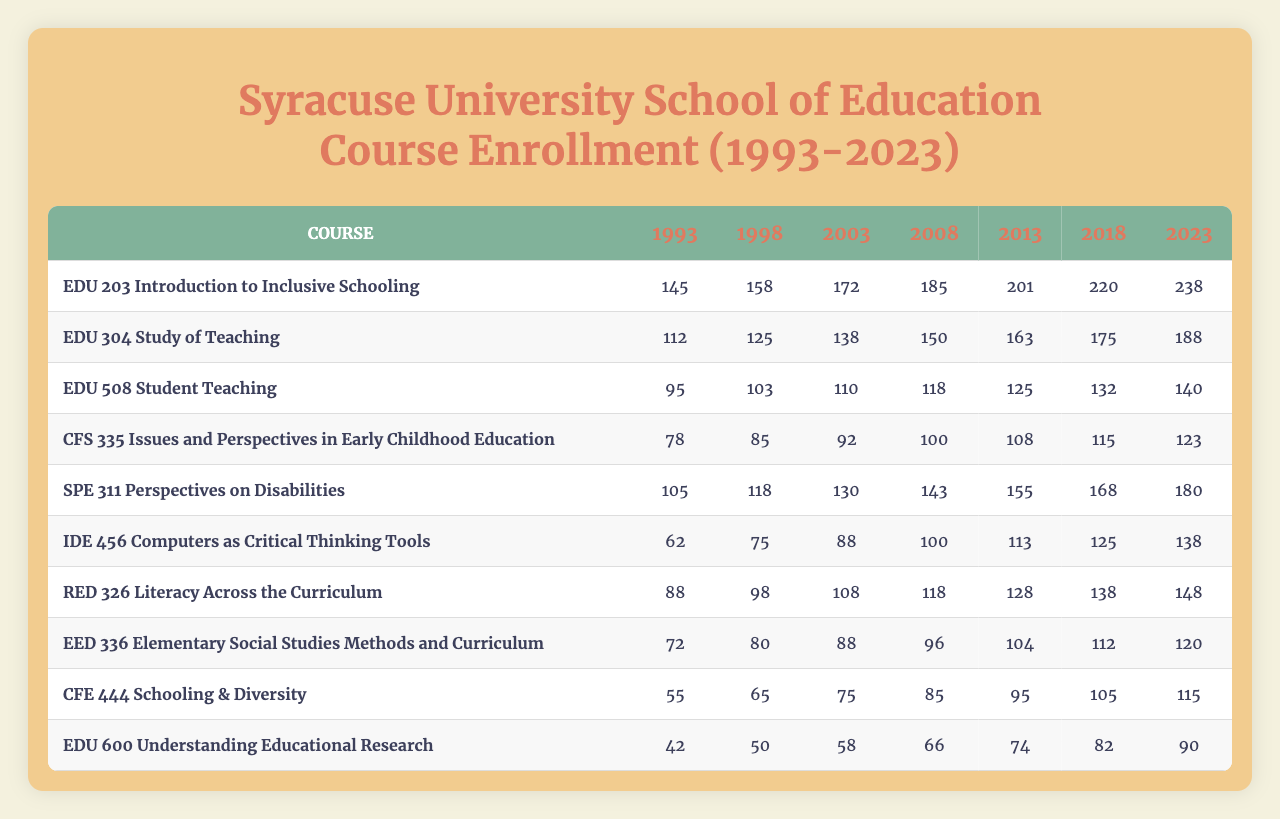What is the enrollment for "EDU 203 Introduction to Inclusive Schooling" in the year 2023? Referring to the table, locate the row for "EDU 203 Introduction to Inclusive Schooling" and find the corresponding value under the year 2023, which is 238.
Answer: 238 What is the highest enrollment recorded for "CFS 335 Issues and Perspectives in Early Childhood Education"? The highest enrollment can be determined by examining the enrollment numbers over the years provided in the row for "CFS 335 Issues and Perspectives in Early Childhood Education". The maximum value is 123 in the year 2023.
Answer: 123 Which course experienced the most significant increase in enrollment from 1993 to 2023? To find the course with the largest increase, calculate the difference between the enrollment numbers for each course in 1993 and 2023. Comparing the calculated differences, "EDU 203 Introduction to Inclusive Schooling" had the highest increase of 93 (from 145 to 238).
Answer: "EDU 203 Introduction to Inclusive Schooling" What is the average enrollment for "SPE 311 Perspectives on Disabilities" over the 30 years? To find the average, add together all enrollment values for "SPE 311 Perspectives on Disabilities" (105 + 118 + 130 + 143 + 155 + 168 + 180 = 999) and then divide by the total number of entries (7). Therefore, 999 / 7 = 142.71, which rounds to 143.
Answer: 143 Is the enrollment for "IDE 456 Computers as Critical Thinking Tools" greater than 100 in 2013? Check the enrollment for "IDE 456 Computers as Critical Thinking Tools" in the year 2013, which is 113. Since 113 is greater than 100, the answer is yes.
Answer: Yes What is the total enrollment for the course "EDU 600 Understanding Educational Research" from 1993 to 2023? The total enrollment is found by summing the values for the course "EDU 600 Understanding Educational Research" (42 + 50 + 58 + 66 + 74 + 82 + 90 = 462).
Answer: 462 Which course has the lowest enrollment in the year 1998? Looking through the enrollment for each course in 1998, "CFE 444 Schooling & Diversity" has the lowest enrollment at 65.
Answer: "CFE 444 Schooling & Diversity" If we compare enrollments, how many more students enrolled in "EDU 304 Study of Teaching" than in "EDU 508 Student Teaching" in 2023? The enrollment in 2023 for "EDU 304 Study of Teaching" is 188 and for "EDU 508 Student Teaching" is 140. Thus, the difference is 188 - 140 = 48.
Answer: 48 How many courses had an enrollment of over 100 students in 2008? Checking the enrollments for 2008, the courses with over 100 students are "EDU 203 Introduction to Inclusive Schooling," "EDU 304 Study of Teaching," "SPE 311 Perspectives on Disabilities," "EDU 508 Student Teaching," "CFS 335 Issues and Perspectives in Early Childhood Education," making it a total of 5 courses.
Answer: 5 What is the trend in enrollment for “RED 326 Literacy Across the Curriculum” from 1993 to 2023? By comparing the enrollment numbers for "RED 326 Literacy Across the Curriculum" over the years, we can see a consistent increase: 88 in 1993 to 148 in 2023, indicating a positive trend.
Answer: Increasing trend 